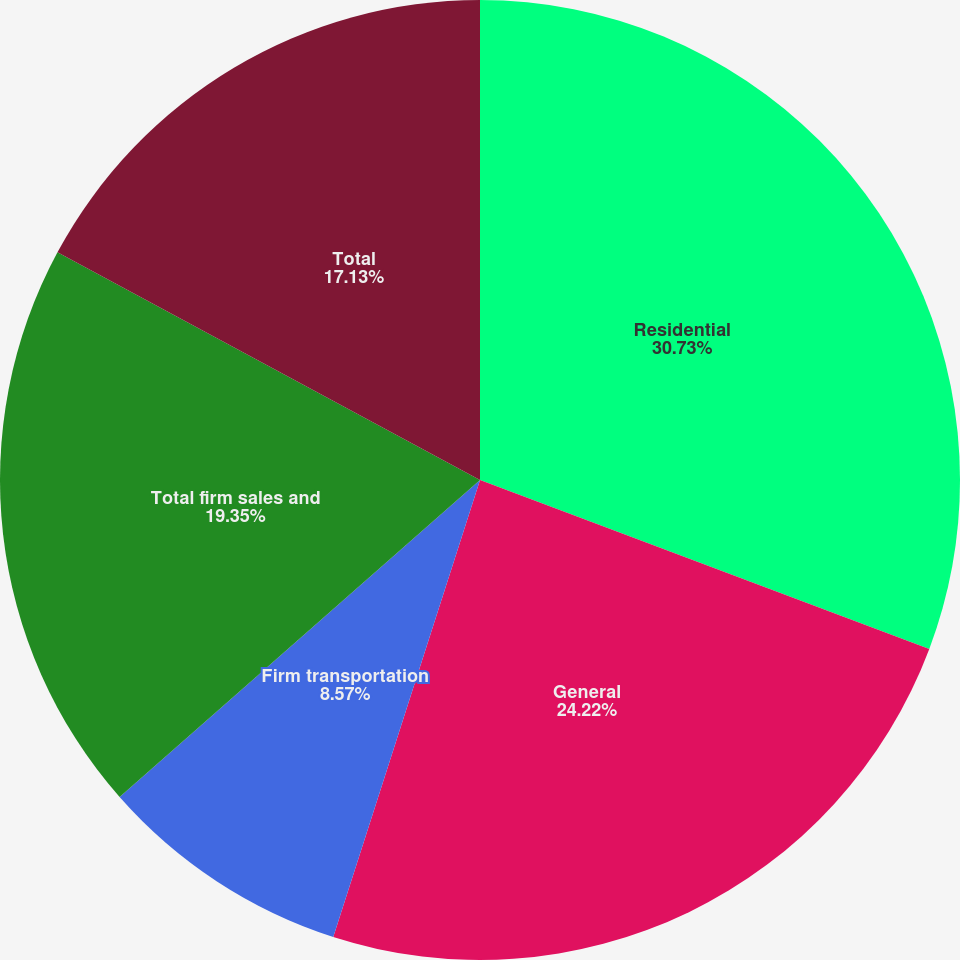<chart> <loc_0><loc_0><loc_500><loc_500><pie_chart><fcel>Residential<fcel>General<fcel>Firm transportation<fcel>Total firm sales and<fcel>Total<nl><fcel>30.72%<fcel>24.22%<fcel>8.57%<fcel>19.35%<fcel>17.13%<nl></chart> 